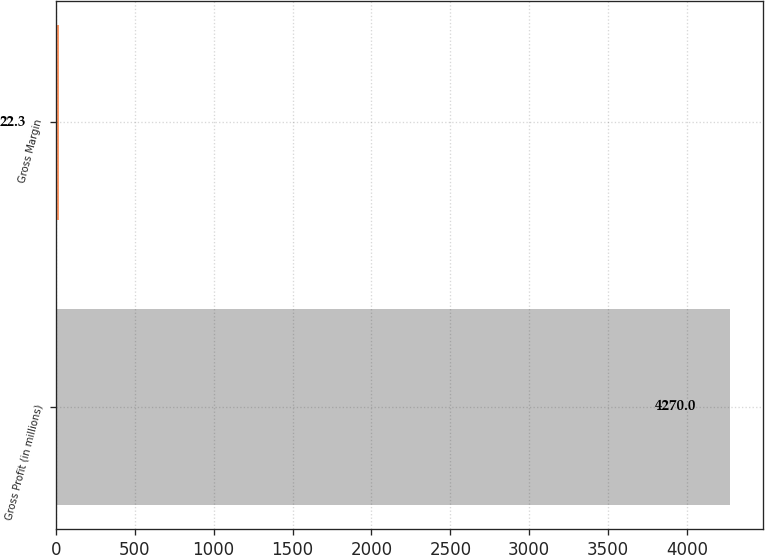Convert chart to OTSL. <chart><loc_0><loc_0><loc_500><loc_500><bar_chart><fcel>Gross Profit (in millions)<fcel>Gross Margin<nl><fcel>4270<fcel>22.3<nl></chart> 